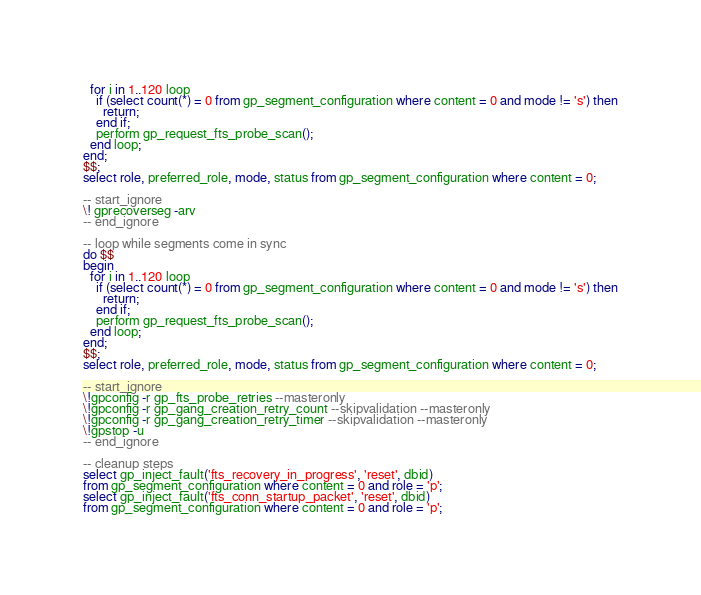Convert code to text. <code><loc_0><loc_0><loc_500><loc_500><_SQL_>  for i in 1..120 loop
    if (select count(*) = 0 from gp_segment_configuration where content = 0 and mode != 's') then
      return;
    end if;
    perform gp_request_fts_probe_scan();
  end loop;
end;
$$;
select role, preferred_role, mode, status from gp_segment_configuration where content = 0;

-- start_ignore
\! gprecoverseg -arv
-- end_ignore

-- loop while segments come in sync
do $$
begin
  for i in 1..120 loop
    if (select count(*) = 0 from gp_segment_configuration where content = 0 and mode != 's') then
      return;
    end if;
    perform gp_request_fts_probe_scan();
  end loop;
end;
$$;
select role, preferred_role, mode, status from gp_segment_configuration where content = 0;

-- start_ignore
\!gpconfig -r gp_fts_probe_retries --masteronly
\!gpconfig -r gp_gang_creation_retry_count --skipvalidation --masteronly
\!gpconfig -r gp_gang_creation_retry_timer --skipvalidation --masteronly
\!gpstop -u
-- end_ignore

-- cleanup steps
select gp_inject_fault('fts_recovery_in_progress', 'reset', dbid)
from gp_segment_configuration where content = 0 and role = 'p';
select gp_inject_fault('fts_conn_startup_packet', 'reset', dbid)
from gp_segment_configuration where content = 0 and role = 'p';
</code> 